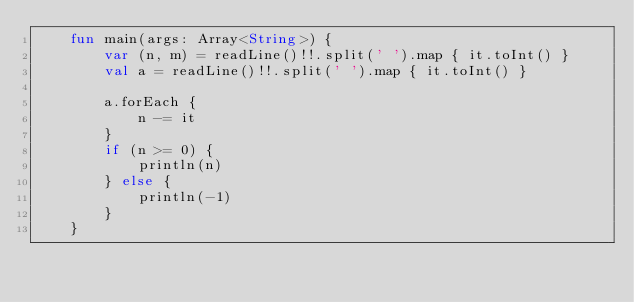Convert code to text. <code><loc_0><loc_0><loc_500><loc_500><_Kotlin_>    fun main(args: Array<String>) {
        var (n, m) = readLine()!!.split(' ').map { it.toInt() }
        val a = readLine()!!.split(' ').map { it.toInt() }

        a.forEach {
            n -= it
        }
        if (n >= 0) {
            println(n)
        } else {
            println(-1)
        }
    }
</code> 